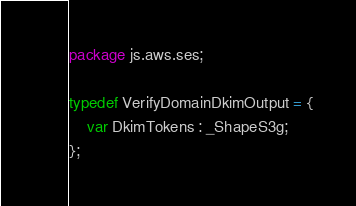Convert code to text. <code><loc_0><loc_0><loc_500><loc_500><_Haxe_>package js.aws.ses;

typedef VerifyDomainDkimOutput = {
    var DkimTokens : _ShapeS3g;
};
</code> 